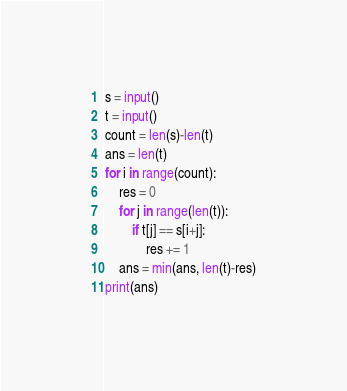Convert code to text. <code><loc_0><loc_0><loc_500><loc_500><_Python_>s = input()
t = input()
count = len(s)-len(t)
ans = len(t)
for i in range(count):
    res = 0
    for j in range(len(t)):
        if t[j] == s[i+j]:
            res += 1
    ans = min(ans, len(t)-res)
print(ans)</code> 